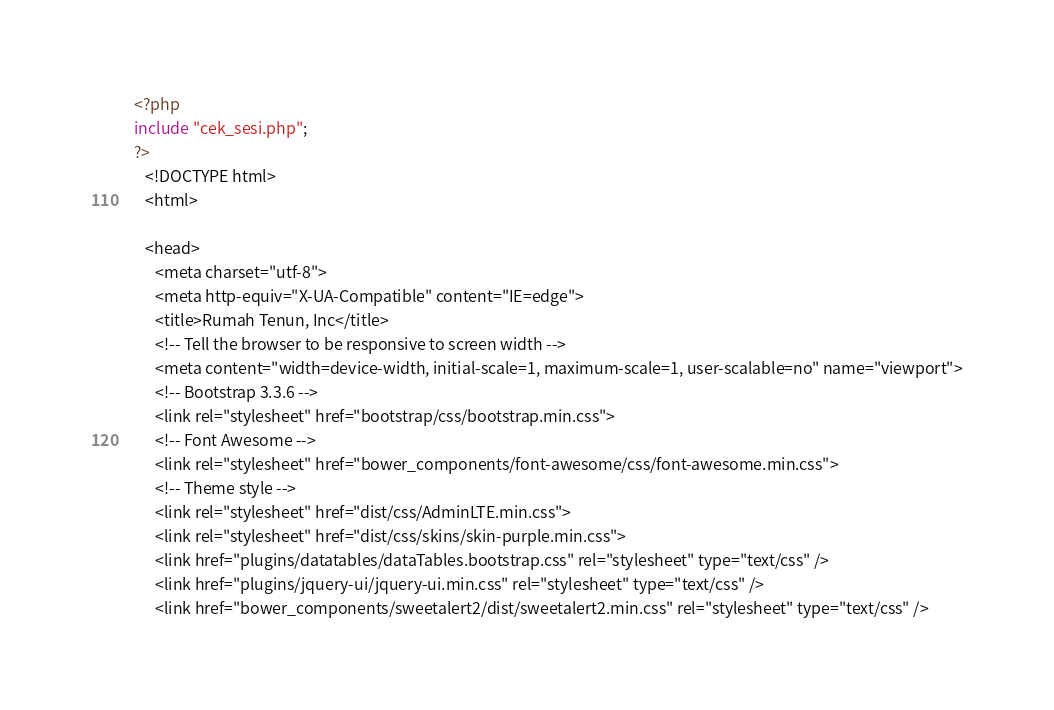<code> <loc_0><loc_0><loc_500><loc_500><_PHP_><?php
include "cek_sesi.php";
?>
   <!DOCTYPE html>
   <html>

   <head>
      <meta charset="utf-8">
      <meta http-equiv="X-UA-Compatible" content="IE=edge">
      <title>Rumah Tenun, Inc</title>
      <!-- Tell the browser to be responsive to screen width -->
      <meta content="width=device-width, initial-scale=1, maximum-scale=1, user-scalable=no" name="viewport">
      <!-- Bootstrap 3.3.6 -->
      <link rel="stylesheet" href="bootstrap/css/bootstrap.min.css">
      <!-- Font Awesome -->
      <link rel="stylesheet" href="bower_components/font-awesome/css/font-awesome.min.css">
      <!-- Theme style -->
      <link rel="stylesheet" href="dist/css/AdminLTE.min.css">
      <link rel="stylesheet" href="dist/css/skins/skin-purple.min.css">
      <link href="plugins/datatables/dataTables.bootstrap.css" rel="stylesheet" type="text/css" />
      <link href="plugins/jquery-ui/jquery-ui.min.css" rel="stylesheet" type="text/css" />
      <link href="bower_components/sweetalert2/dist/sweetalert2.min.css" rel="stylesheet" type="text/css" /></code> 